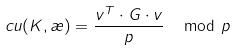Convert formula to latex. <formula><loc_0><loc_0><loc_500><loc_500>c u ( K , \rho ) = \frac { v ^ { T } \cdot G \cdot v } { p } \, \mod p</formula> 